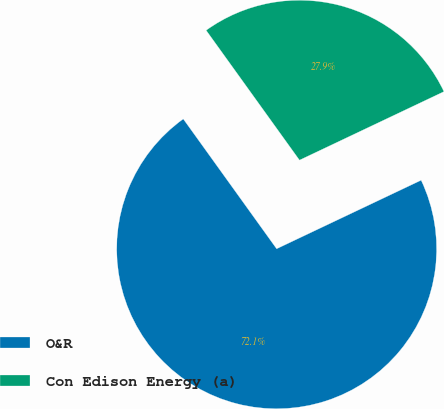Convert chart. <chart><loc_0><loc_0><loc_500><loc_500><pie_chart><fcel>O&R<fcel>Con Edison Energy (a)<nl><fcel>72.13%<fcel>27.87%<nl></chart> 